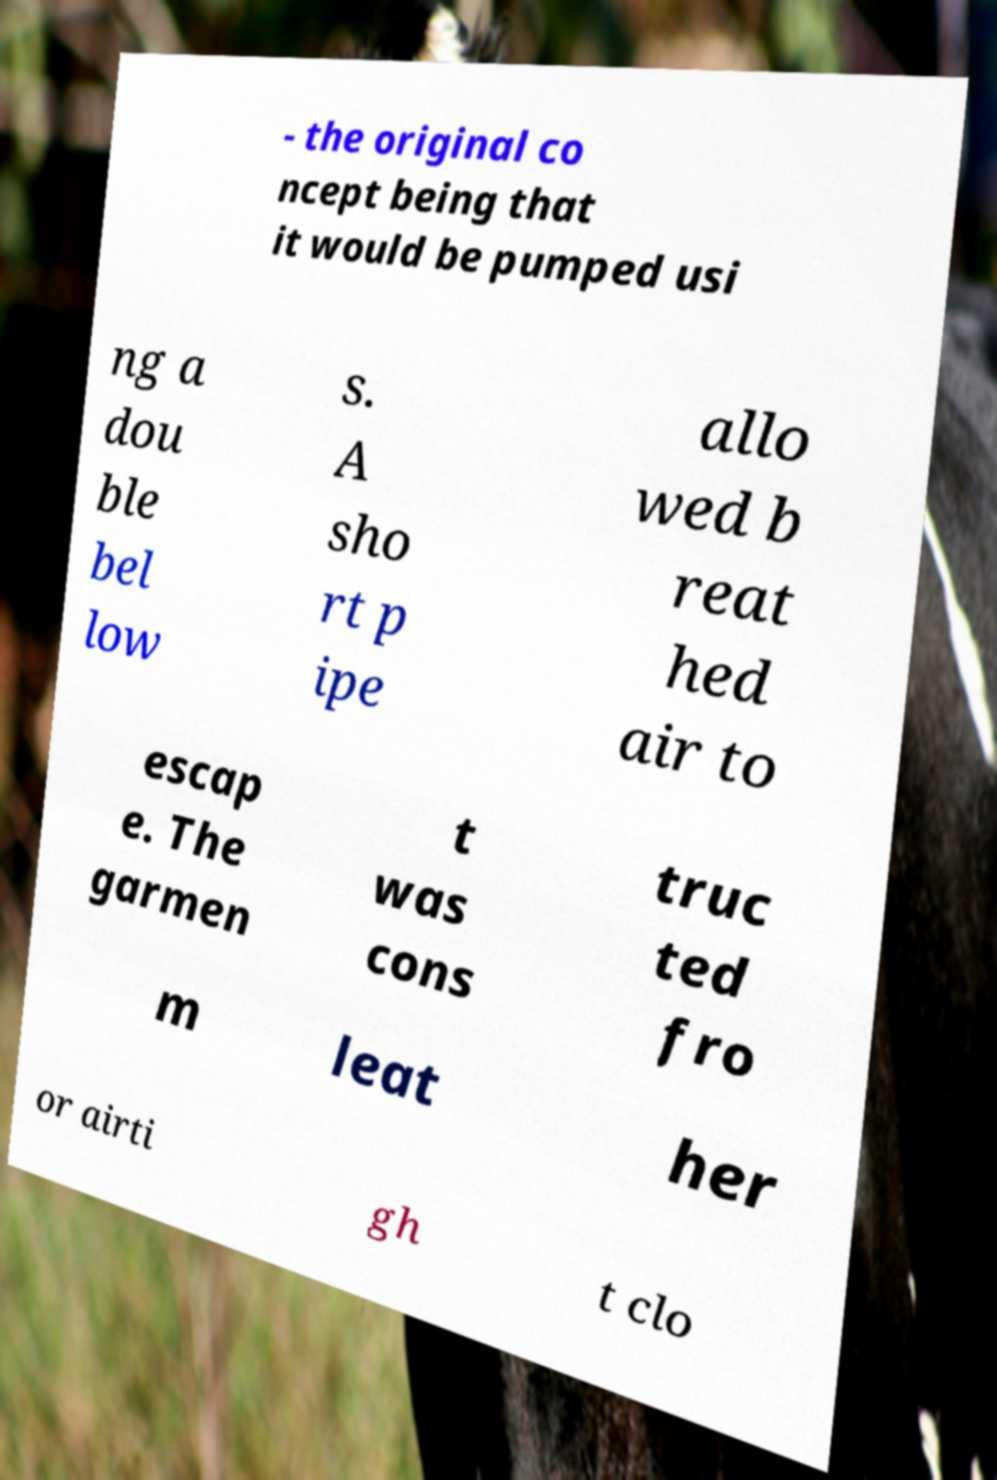Could you assist in decoding the text presented in this image and type it out clearly? - the original co ncept being that it would be pumped usi ng a dou ble bel low s. A sho rt p ipe allo wed b reat hed air to escap e. The garmen t was cons truc ted fro m leat her or airti gh t clo 